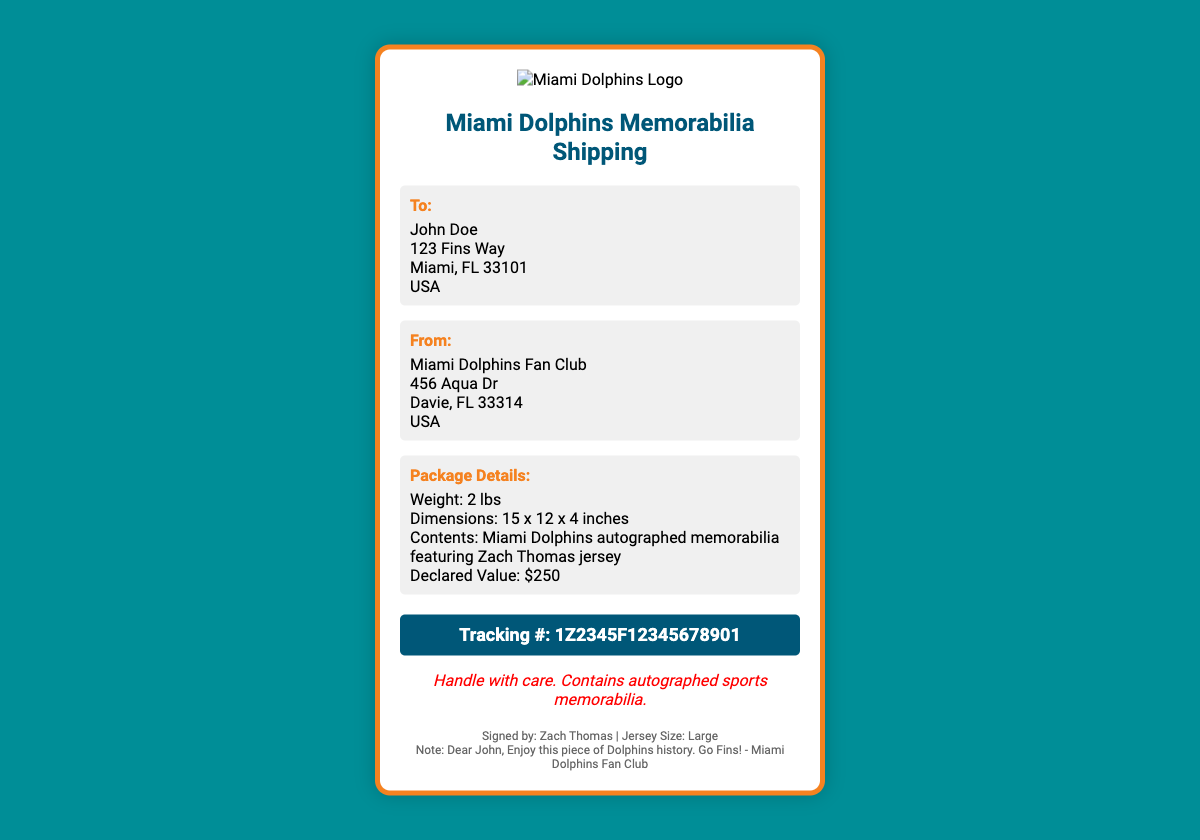What is the recipient's name? The recipient's name is listed in the "To:" section of the label.
Answer: John Doe What is the declared value of the package? The declared value is stated in the "Package Details" section.
Answer: $250 What is the tracking number? The tracking number is provided in the "tracking" section of the label.
Answer: 1Z2345F12345678901 What item is included in the package? The included item is detailed in the "Package Details" section.
Answer: Miami Dolphins autographed memorabilia featuring Zach Thomas jersey Where is the sender located? The sender's address is listed in the "From:" section of the label.
Answer: 456 Aqua Dr, Davie, FL 33314, USA What color is the packaging? The color of the packaging can be inferred from the sea colors representing the Miami Dolphins.
Answer: Aqua and orange What size is the jersey? The jersey size is mentioned in the "footer" section of the label.
Answer: Large What special instructions are provided? The special instructions are indicated on the label for handling.
Answer: Handle with care. Contains autographed sports memorabilia What message is written in the note? The note is included in the "footer" section, providing a personal touch from the sender.
Answer: Enjoy this piece of Dolphins history. Go Fins! - Miami Dolphins Fan Club 